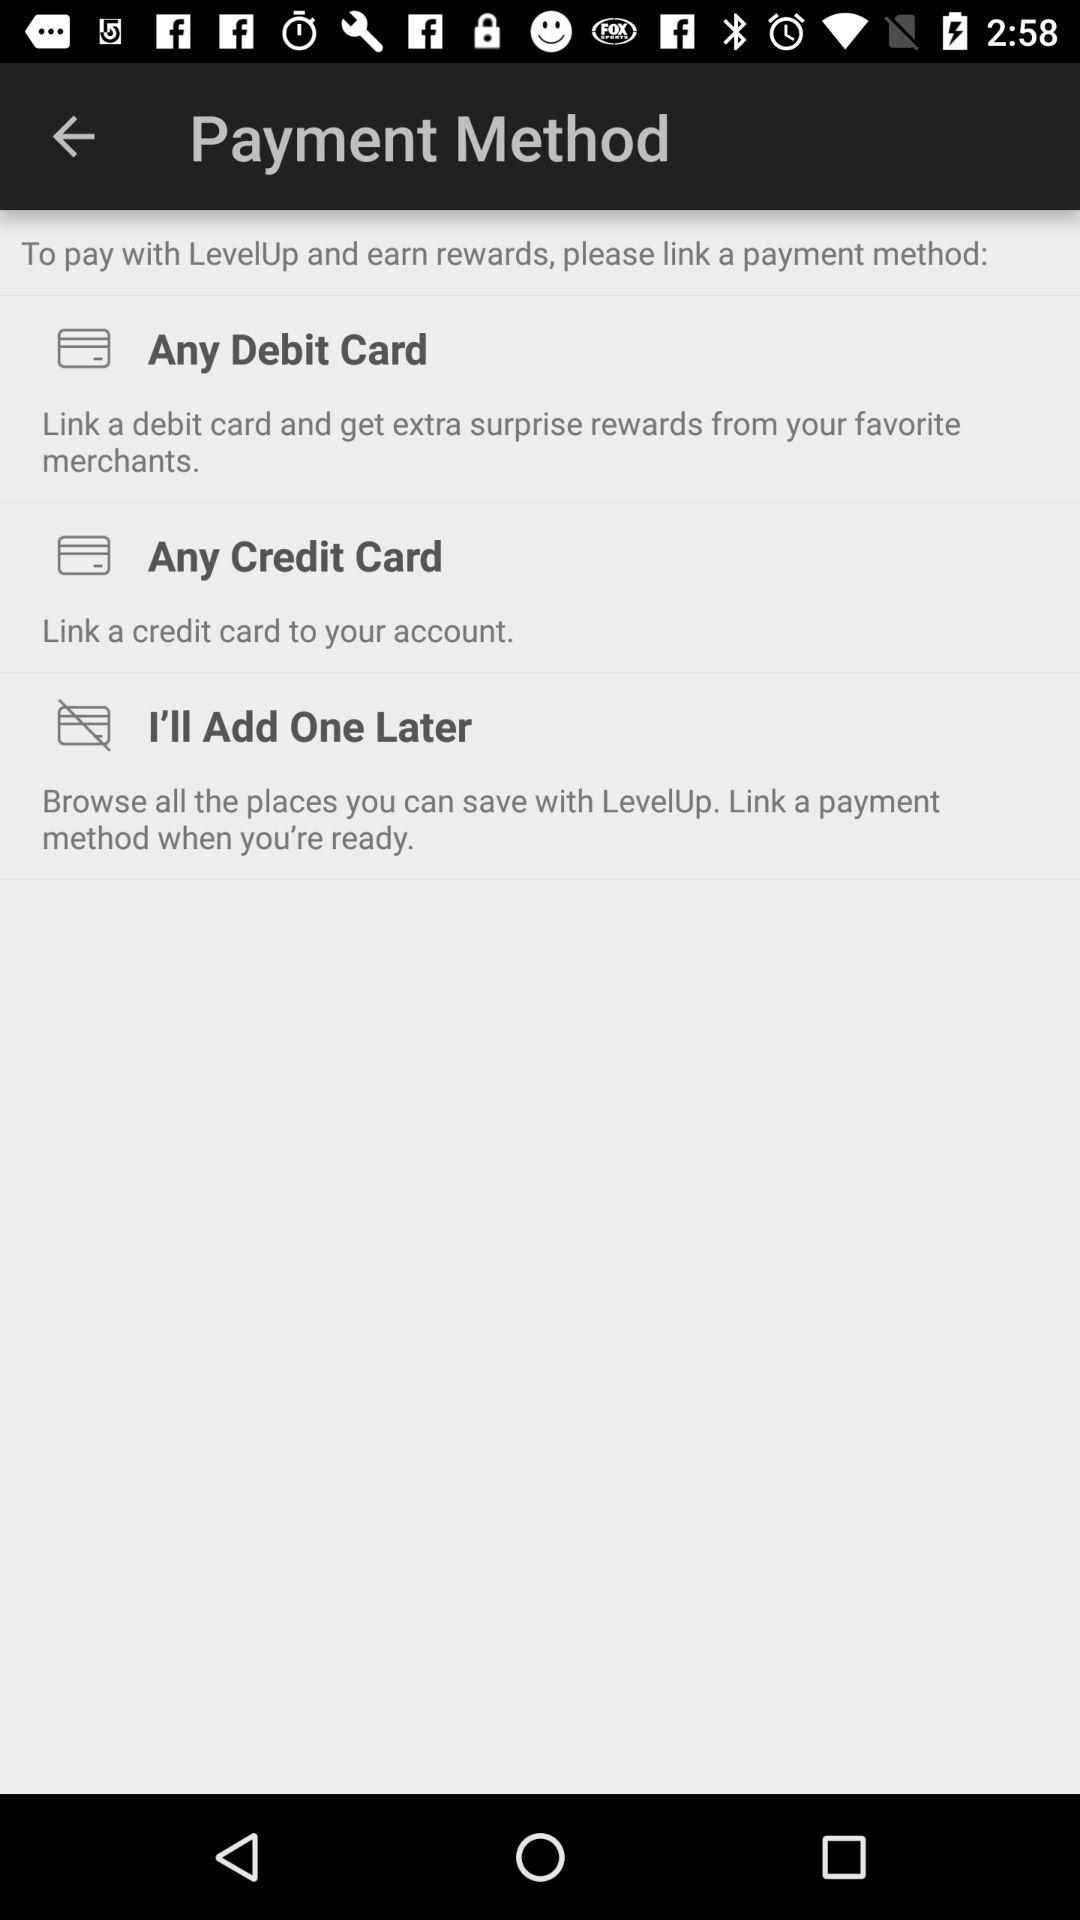How can the user get extra surprise rewards from their favorite merchants? The user can link a debit card and get extra surprise rewards from their favorite merchants. 